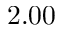Convert formula to latex. <formula><loc_0><loc_0><loc_500><loc_500>2 . 0 0</formula> 